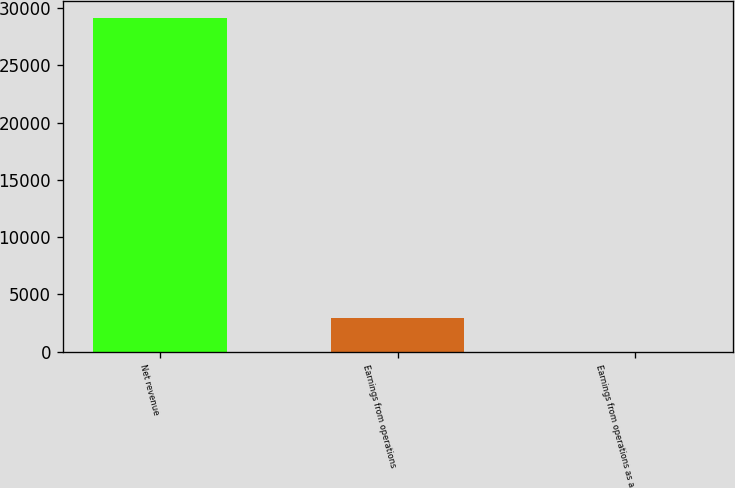Convert chart to OTSL. <chart><loc_0><loc_0><loc_500><loc_500><bar_chart><fcel>Net revenue<fcel>Earnings from operations<fcel>Earnings from operations as a<nl><fcel>29166<fcel>2920.11<fcel>3.9<nl></chart> 